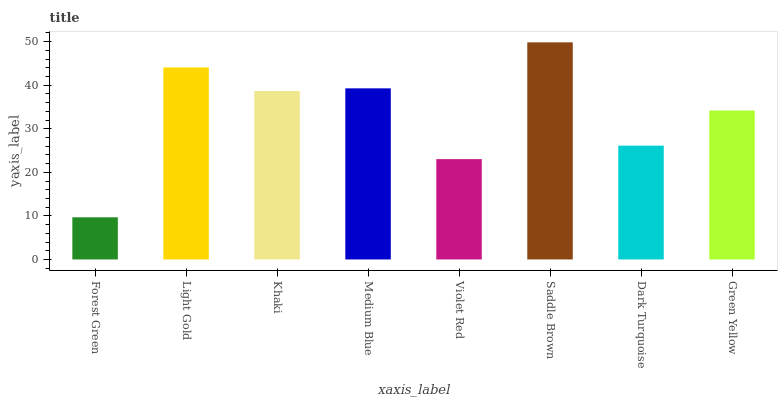Is Forest Green the minimum?
Answer yes or no. Yes. Is Saddle Brown the maximum?
Answer yes or no. Yes. Is Light Gold the minimum?
Answer yes or no. No. Is Light Gold the maximum?
Answer yes or no. No. Is Light Gold greater than Forest Green?
Answer yes or no. Yes. Is Forest Green less than Light Gold?
Answer yes or no. Yes. Is Forest Green greater than Light Gold?
Answer yes or no. No. Is Light Gold less than Forest Green?
Answer yes or no. No. Is Khaki the high median?
Answer yes or no. Yes. Is Green Yellow the low median?
Answer yes or no. Yes. Is Medium Blue the high median?
Answer yes or no. No. Is Khaki the low median?
Answer yes or no. No. 